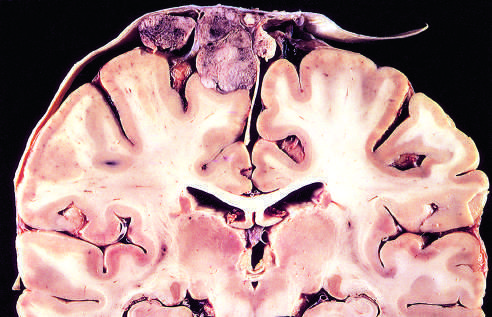how is parasagittal multilobular meningioma attached?
Answer the question using a single word or phrase. To the dura with compression of underlying brain 